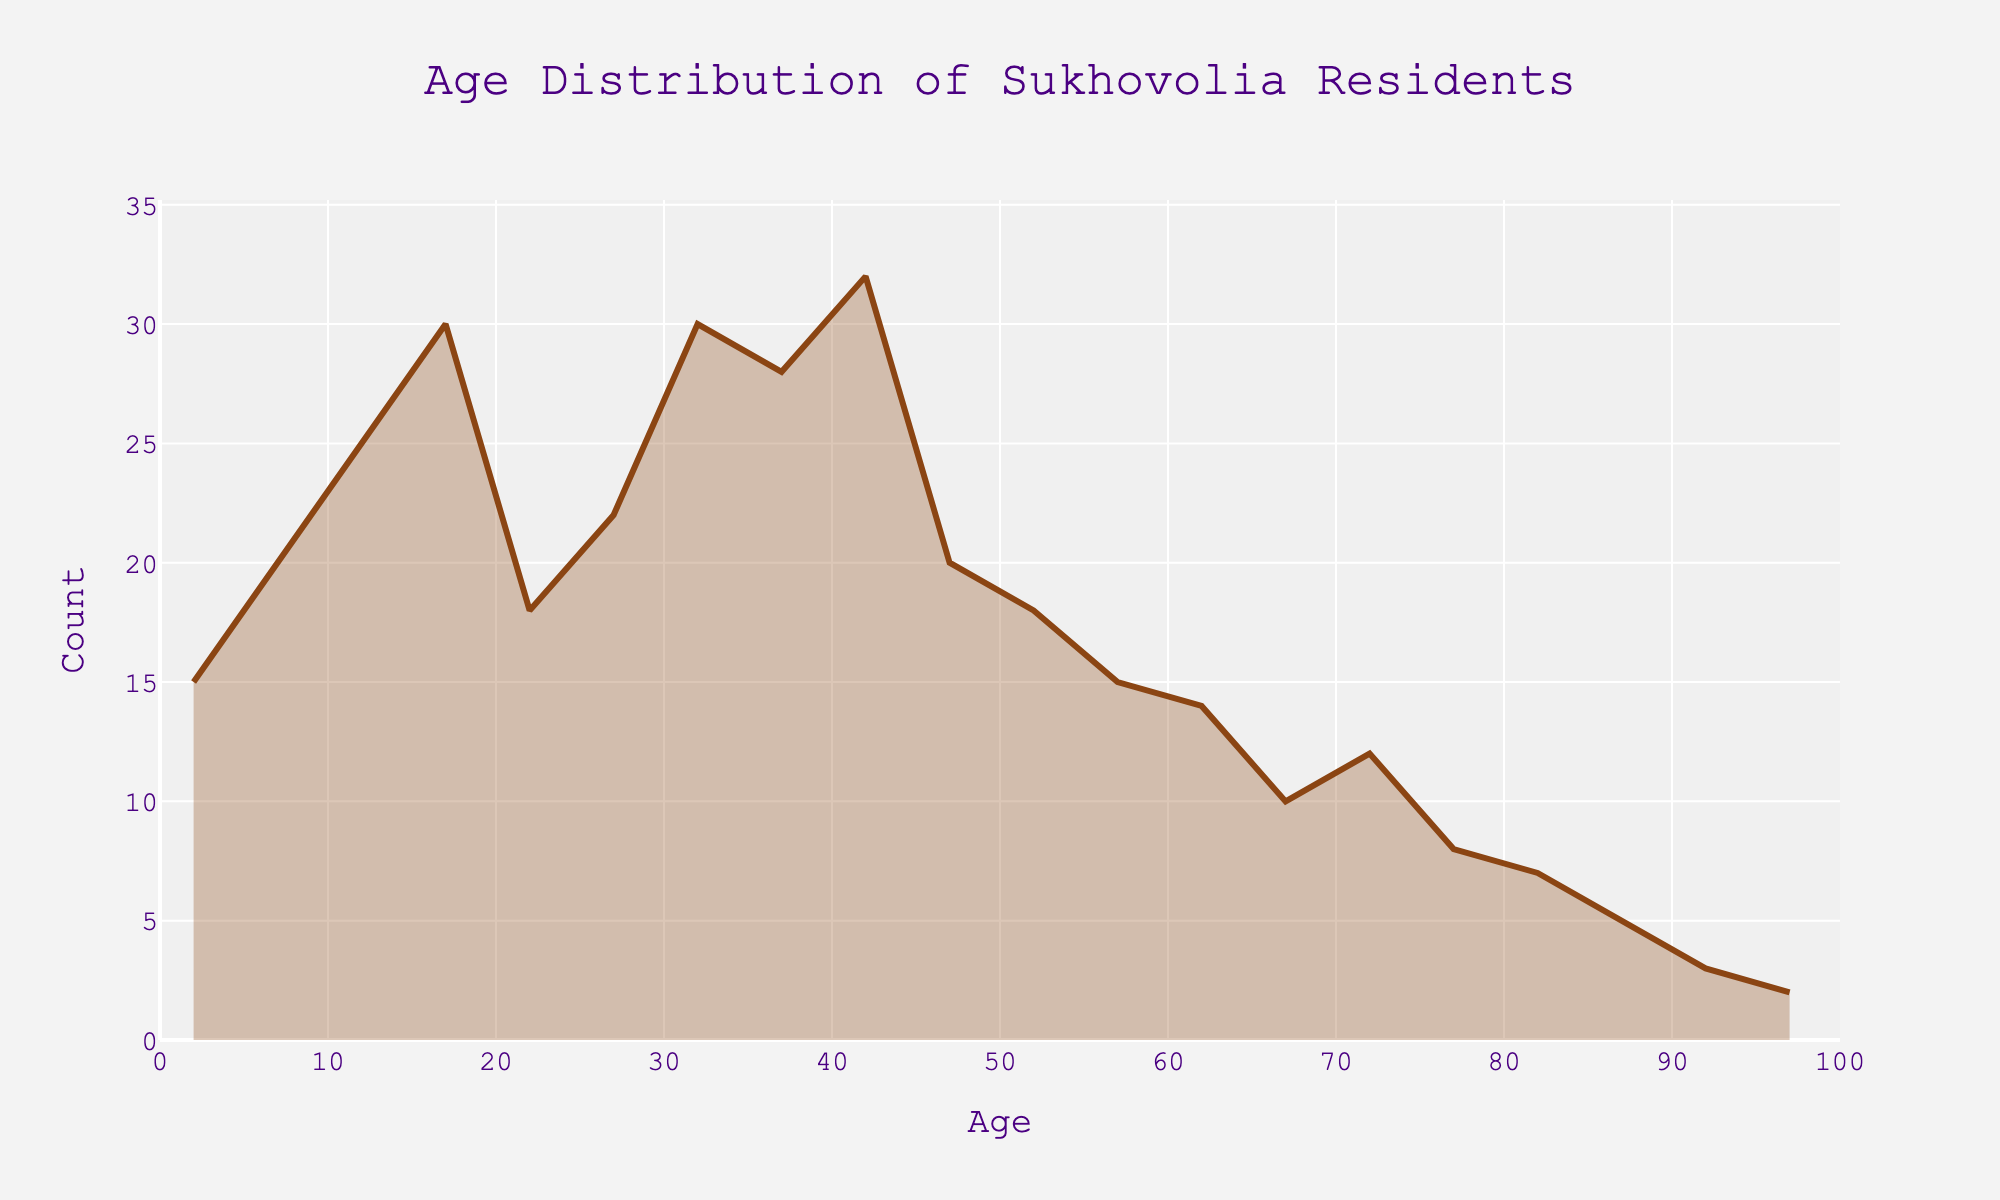What is the range of age groups displayed in the plot? The age groups range from 0-4 to 95-99, covering the entire lifespan including very young children and elderly residents.
Answer: 0-4 to 95-99 What is the title of the figure? The title is displayed at the top center of the plot, indicating what data is being presented.
Answer: Age Distribution of Sukhovolia Residents How many age groups have more than 25 residents? By looking at the count on the y-axis, the age groups 10-14, 15-19, 30-34, and 40-44 have values exceeding 25 residents.
Answer: 4 Which age group has the highest count of residents? By observing the peak of the density plot, the highest count is at the 40-44 age group.
Answer: 40-44 What is the total number of residents in the age groups from 0-4 to 10-14? Add the counts of the age groups 0-4 (15), 5-9 (20), and 10-14 (25): 15 + 20 + 25 = 60.
Answer: 60 Which age group has the lowest count of residents? The lowest count occurs at the right extreme of the plot, in the age group 95-99.
Answer: 95-99 Compare the counts of residents in the age groups 20-24 and 45-49. Which one is higher? The plot shows that the count for 45-49 (20) exceeds the count for 20-24 (18).
Answer: 45-49 What is the count of residents in the age group 65-69? By locating the count on the y-axis corresponding to 65-69 on the x-axis, it is evident there are 10 residents.
Answer: 10 What age groups have exactly 18 residents? The density plot indicates the age groups 20-24 and 50-54 have counts of 18 residents each.
Answer: 2 Between the age groups 30-34 and 35-39, which has more residents? According to the plot, both the age groups of 30-34 and 35-39 have similar counts lying around 30 residents. However, counting directly, each exact value reveals they each have 30 residents.
Answer: Equal 